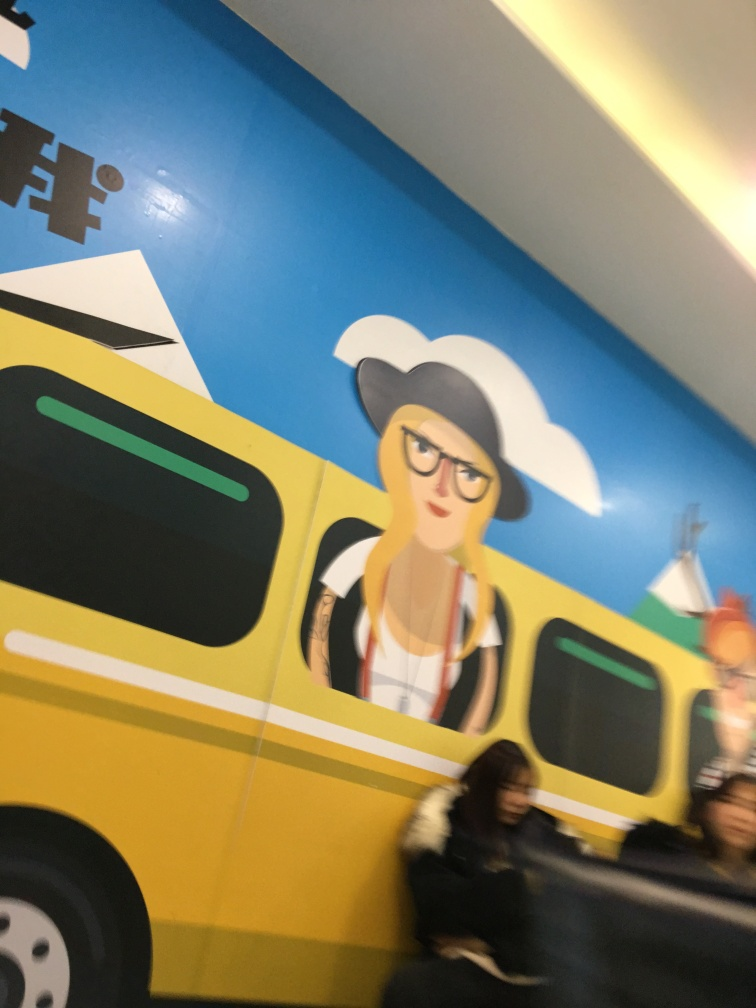Could you speculate on what the mural might be trying to convey or represent? The mural's design features vibrant colors and a modern aesthetic, perhaps conveying a sense of urban energy or celebrating local culture and transportation. The central figure, a character with an air of confidence and style, might represent the diversity and youthfulness of the city's population, endorsing a message of inclusive community identity or the dynamism of urban life. 